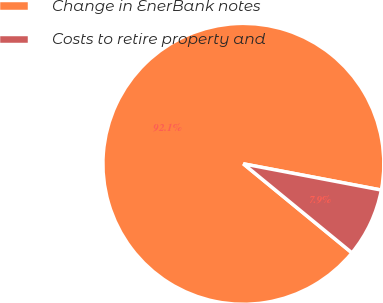Convert chart. <chart><loc_0><loc_0><loc_500><loc_500><pie_chart><fcel>Change in EnerBank notes<fcel>Costs to retire property and<nl><fcel>92.06%<fcel>7.94%<nl></chart> 